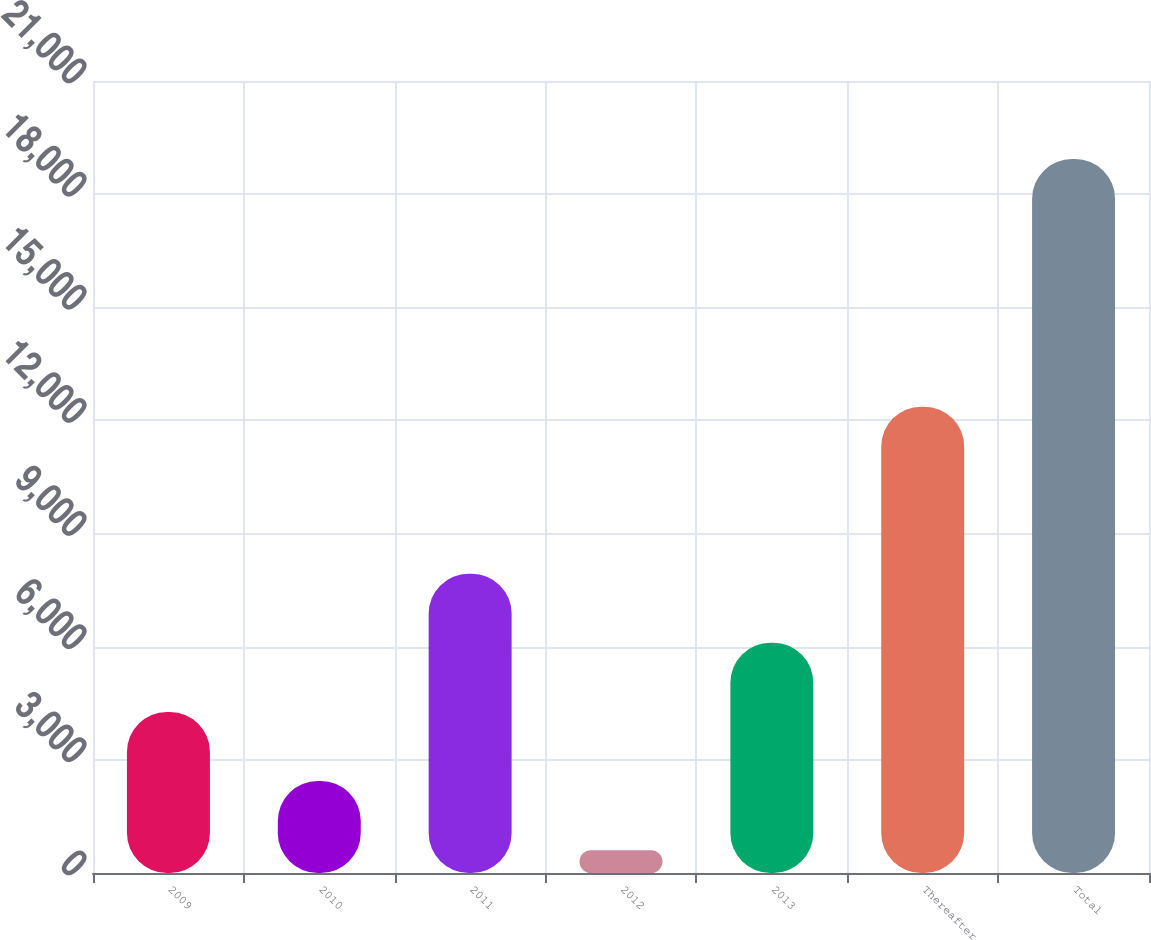Convert chart to OTSL. <chart><loc_0><loc_0><loc_500><loc_500><bar_chart><fcel>2009<fcel>2010<fcel>2011<fcel>2012<fcel>2013<fcel>Thereafter<fcel>Total<nl><fcel>4270.88<fcel>2437.99<fcel>7936.66<fcel>605.1<fcel>6103.77<fcel>12365.3<fcel>18934<nl></chart> 